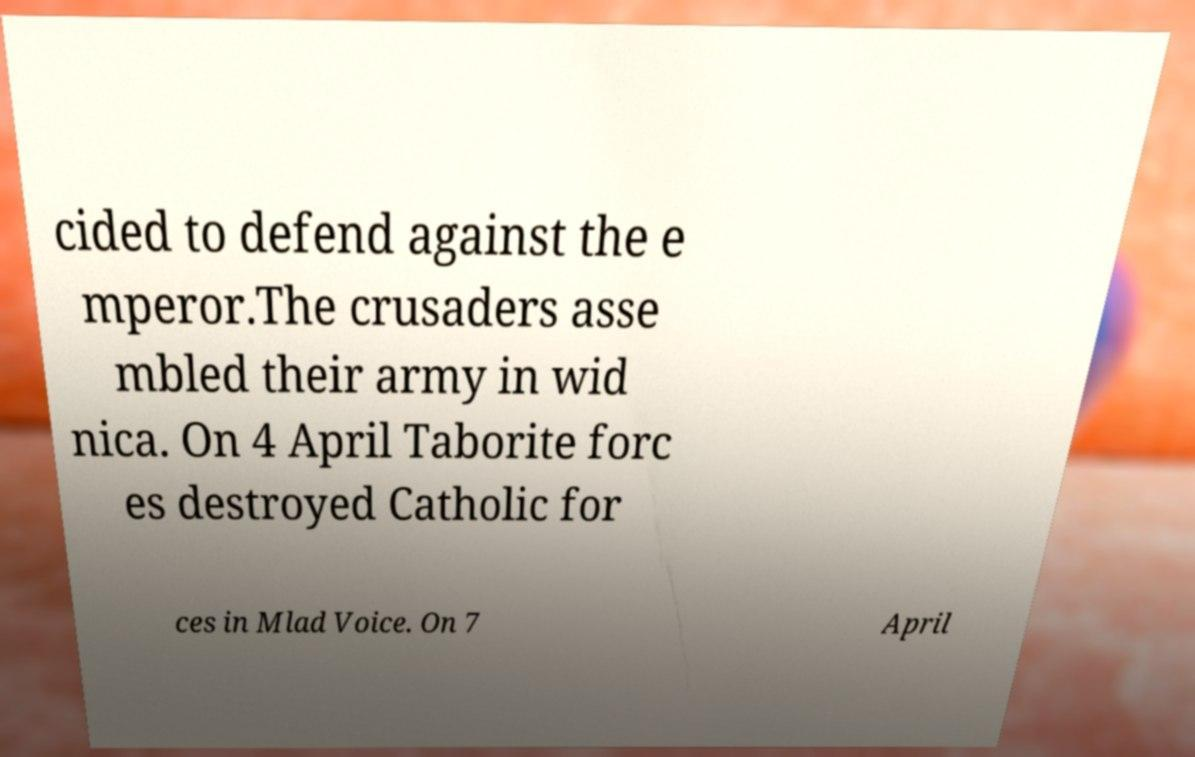Please read and relay the text visible in this image. What does it say? cided to defend against the e mperor.The crusaders asse mbled their army in wid nica. On 4 April Taborite forc es destroyed Catholic for ces in Mlad Voice. On 7 April 